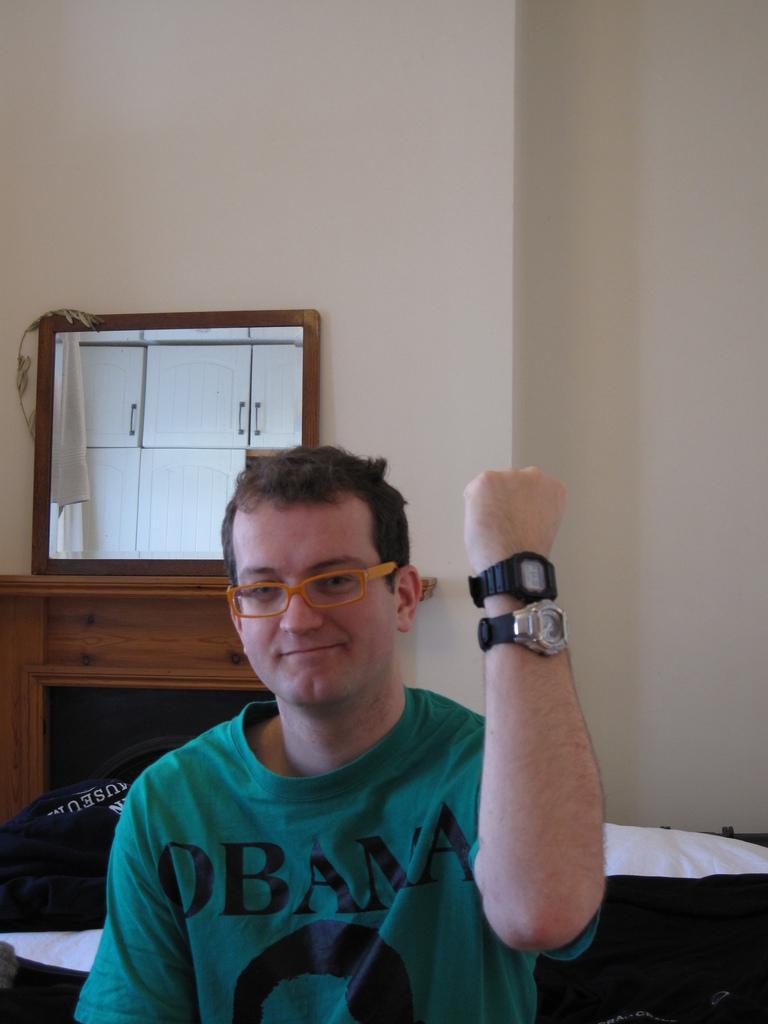Describe this image in one or two sentences. In this image there is a person wearing spectacles and watches. Behind him there are objects on the bed. Left side there is a wooden furniture having a mirror. Background there is a wall. 